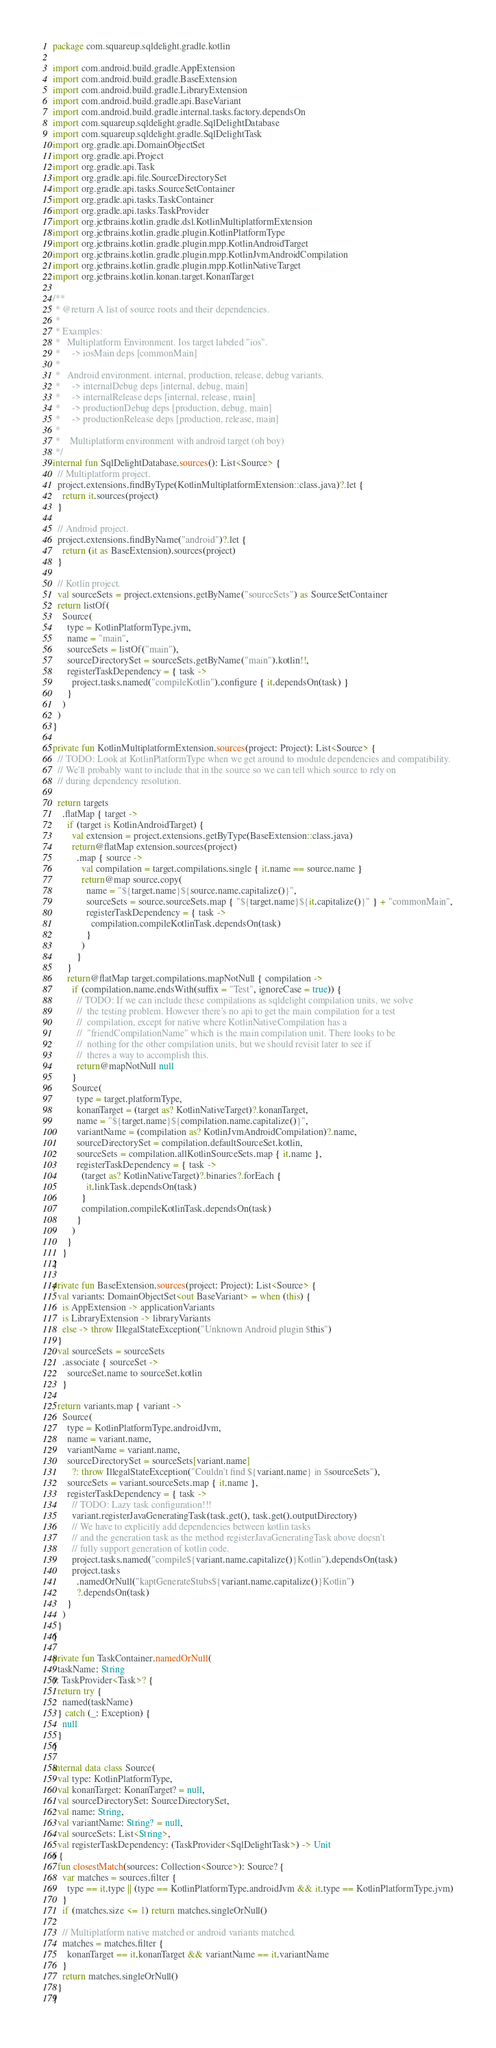Convert code to text. <code><loc_0><loc_0><loc_500><loc_500><_Kotlin_>package com.squareup.sqldelight.gradle.kotlin

import com.android.build.gradle.AppExtension
import com.android.build.gradle.BaseExtension
import com.android.build.gradle.LibraryExtension
import com.android.build.gradle.api.BaseVariant
import com.android.build.gradle.internal.tasks.factory.dependsOn
import com.squareup.sqldelight.gradle.SqlDelightDatabase
import com.squareup.sqldelight.gradle.SqlDelightTask
import org.gradle.api.DomainObjectSet
import org.gradle.api.Project
import org.gradle.api.Task
import org.gradle.api.file.SourceDirectorySet
import org.gradle.api.tasks.SourceSetContainer
import org.gradle.api.tasks.TaskContainer
import org.gradle.api.tasks.TaskProvider
import org.jetbrains.kotlin.gradle.dsl.KotlinMultiplatformExtension
import org.jetbrains.kotlin.gradle.plugin.KotlinPlatformType
import org.jetbrains.kotlin.gradle.plugin.mpp.KotlinAndroidTarget
import org.jetbrains.kotlin.gradle.plugin.mpp.KotlinJvmAndroidCompilation
import org.jetbrains.kotlin.gradle.plugin.mpp.KotlinNativeTarget
import org.jetbrains.kotlin.konan.target.KonanTarget

/**
 * @return A list of source roots and their dependencies.
 *
 * Examples:
 *   Multiplatform Environment. Ios target labeled "ios".
 *     -> iosMain deps [commonMain]
 *
 *   Android environment. internal, production, release, debug variants.
 *     -> internalDebug deps [internal, debug, main]
 *     -> internalRelease deps [internal, release, main]
 *     -> productionDebug deps [production, debug, main]
 *     -> productionRelease deps [production, release, main]
 *
 *    Multiplatform environment with android target (oh boy)
 */
internal fun SqlDelightDatabase.sources(): List<Source> {
  // Multiplatform project.
  project.extensions.findByType(KotlinMultiplatformExtension::class.java)?.let {
    return it.sources(project)
  }

  // Android project.
  project.extensions.findByName("android")?.let {
    return (it as BaseExtension).sources(project)
  }

  // Kotlin project.
  val sourceSets = project.extensions.getByName("sourceSets") as SourceSetContainer
  return listOf(
    Source(
      type = KotlinPlatformType.jvm,
      name = "main",
      sourceSets = listOf("main"),
      sourceDirectorySet = sourceSets.getByName("main").kotlin!!,
      registerTaskDependency = { task ->
        project.tasks.named("compileKotlin").configure { it.dependsOn(task) }
      }
    )
  )
}

private fun KotlinMultiplatformExtension.sources(project: Project): List<Source> {
  // TODO: Look at KotlinPlatformType when we get around to module dependencies and compatibility.
  // We'll probably want to include that in the source so we can tell which source to rely on
  // during dependency resolution.

  return targets
    .flatMap { target ->
      if (target is KotlinAndroidTarget) {
        val extension = project.extensions.getByType(BaseExtension::class.java)
        return@flatMap extension.sources(project)
          .map { source ->
            val compilation = target.compilations.single { it.name == source.name }
            return@map source.copy(
              name = "${target.name}${source.name.capitalize()}",
              sourceSets = source.sourceSets.map { "${target.name}${it.capitalize()}" } + "commonMain",
              registerTaskDependency = { task ->
                compilation.compileKotlinTask.dependsOn(task)
              }
            )
          }
      }
      return@flatMap target.compilations.mapNotNull { compilation ->
        if (compilation.name.endsWith(suffix = "Test", ignoreCase = true)) {
          // TODO: If we can include these compilations as sqldelight compilation units, we solve
          //  the testing problem. However there's no api to get the main compilation for a test
          //  compilation, except for native where KotlinNativeCompilation has a
          //  "friendCompilationName" which is the main compilation unit. There looks to be
          //  nothing for the other compilation units, but we should revisit later to see if
          //  theres a way to accomplish this.
          return@mapNotNull null
        }
        Source(
          type = target.platformType,
          konanTarget = (target as? KotlinNativeTarget)?.konanTarget,
          name = "${target.name}${compilation.name.capitalize()}",
          variantName = (compilation as? KotlinJvmAndroidCompilation)?.name,
          sourceDirectorySet = compilation.defaultSourceSet.kotlin,
          sourceSets = compilation.allKotlinSourceSets.map { it.name },
          registerTaskDependency = { task ->
            (target as? KotlinNativeTarget)?.binaries?.forEach {
              it.linkTask.dependsOn(task)
            }
            compilation.compileKotlinTask.dependsOn(task)
          }
        )
      }
    }
}

private fun BaseExtension.sources(project: Project): List<Source> {
  val variants: DomainObjectSet<out BaseVariant> = when (this) {
    is AppExtension -> applicationVariants
    is LibraryExtension -> libraryVariants
    else -> throw IllegalStateException("Unknown Android plugin $this")
  }
  val sourceSets = sourceSets
    .associate { sourceSet ->
      sourceSet.name to sourceSet.kotlin
    }

  return variants.map { variant ->
    Source(
      type = KotlinPlatformType.androidJvm,
      name = variant.name,
      variantName = variant.name,
      sourceDirectorySet = sourceSets[variant.name]
        ?: throw IllegalStateException("Couldn't find ${variant.name} in $sourceSets"),
      sourceSets = variant.sourceSets.map { it.name },
      registerTaskDependency = { task ->
        // TODO: Lazy task configuration!!!
        variant.registerJavaGeneratingTask(task.get(), task.get().outputDirectory)
        // We have to explicitly add dependencies between kotlin tasks
        // and the generation task as the method registerJavaGeneratingTask above doesn't
        // fully support generation of kotlin code.
        project.tasks.named("compile${variant.name.capitalize()}Kotlin").dependsOn(task)
        project.tasks
          .namedOrNull("kaptGenerateStubs${variant.name.capitalize()}Kotlin")
          ?.dependsOn(task)
      }
    )
  }
}

private fun TaskContainer.namedOrNull(
  taskName: String
): TaskProvider<Task>? {
  return try {
    named(taskName)
  } catch (_: Exception) {
    null
  }
}

internal data class Source(
  val type: KotlinPlatformType,
  val konanTarget: KonanTarget? = null,
  val sourceDirectorySet: SourceDirectorySet,
  val name: String,
  val variantName: String? = null,
  val sourceSets: List<String>,
  val registerTaskDependency: (TaskProvider<SqlDelightTask>) -> Unit
) {
  fun closestMatch(sources: Collection<Source>): Source? {
    var matches = sources.filter {
      type == it.type || (type == KotlinPlatformType.androidJvm && it.type == KotlinPlatformType.jvm)
    }
    if (matches.size <= 1) return matches.singleOrNull()

    // Multiplatform native matched or android variants matched.
    matches = matches.filter {
      konanTarget == it.konanTarget && variantName == it.variantName
    }
    return matches.singleOrNull()
  }
}
</code> 